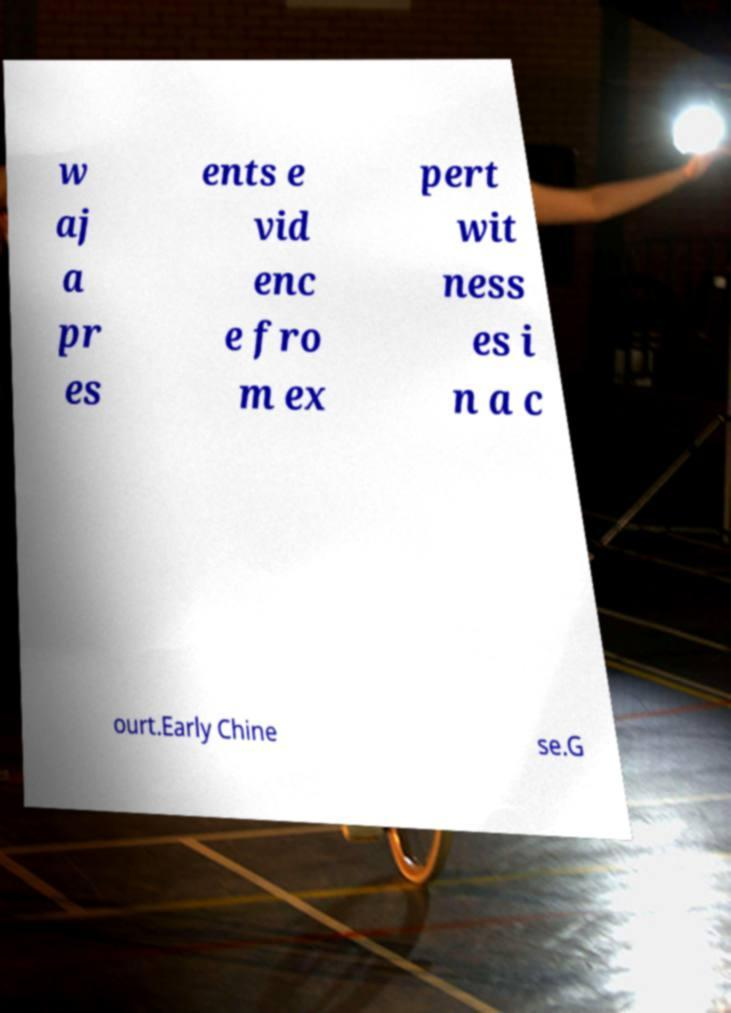Could you extract and type out the text from this image? w aj a pr es ents e vid enc e fro m ex pert wit ness es i n a c ourt.Early Chine se.G 